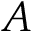Convert formula to latex. <formula><loc_0><loc_0><loc_500><loc_500>A</formula> 